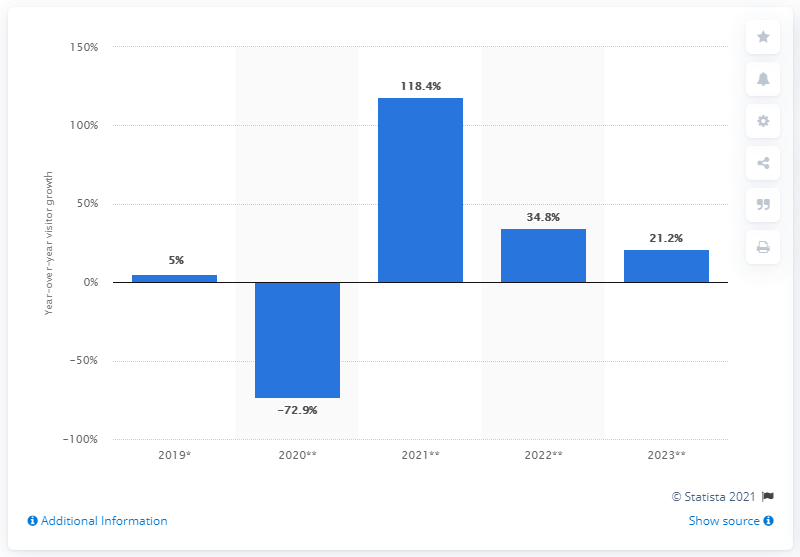Outline some significant characteristics in this image. The forecasted percentage of inbound tourists to Africa by 2023 is expected to be 21.2%. 